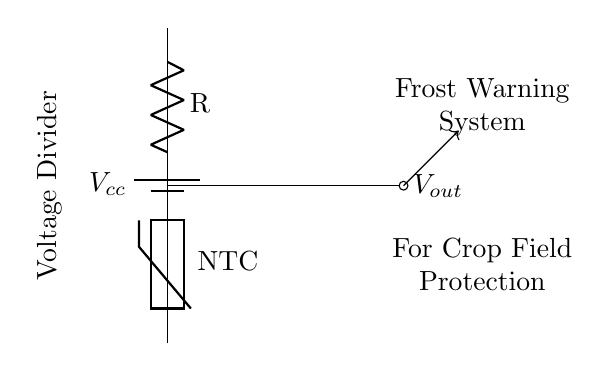What is the purpose of this circuit? The circuit serves as a frost warning system for crop fields, utilizing a thermistor in a voltage divider to monitor temperature changes.
Answer: Frost warning system What type of resistor is used in this circuit? The circuit contains a thermistor, which is a type of resistor specifically designed to change resistance based on temperature, and is marked as NTC (Negative Temperature Coefficient).
Answer: Thermistor What is the output node labeled as? The output node is labeled as Vout, which represents the voltage output from the voltage divider.
Answer: Vout Which component decreases its resistance as temperature increases? The thermistor used in this circuit has an NTC characteristic, meaning its resistance decreases as the temperature rises.
Answer: Thermistor How many components are there in the voltage divider section? The voltage divider consists of two main components: a resistor and a thermistor connected in series.
Answer: Two What is the significance of the voltage divider in this application? The voltage divider converts the varying resistance of the thermistor into a voltage, which can be monitored to provide an indication of temperature, thus signaling frost conditions.
Answer: Converts resistance to voltage What does Vcc represent in the circuit? Vcc represents the supply voltage provided to the circuit, which powers the entire voltage divider arrangement.
Answer: Supply voltage 